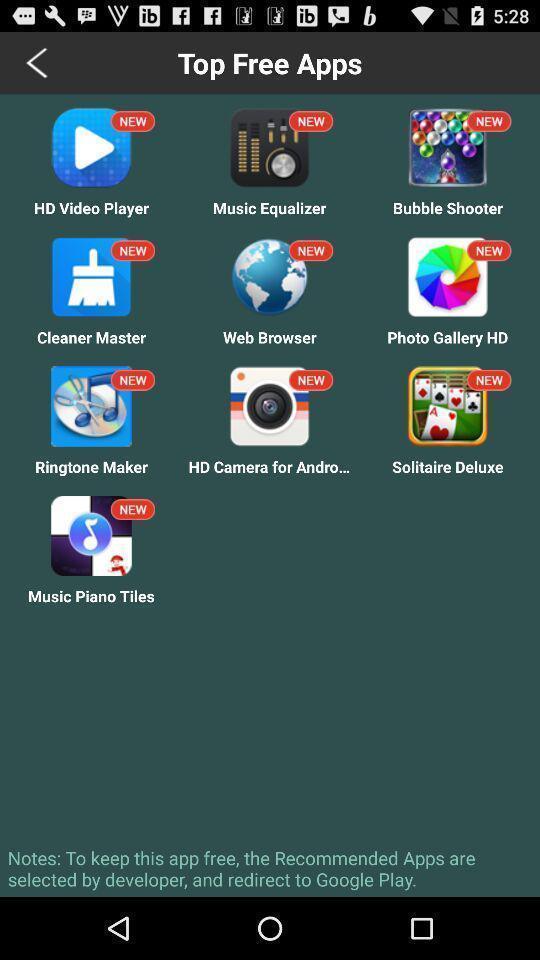Explain what's happening in this screen capture. Page showing the list of top free apps. 